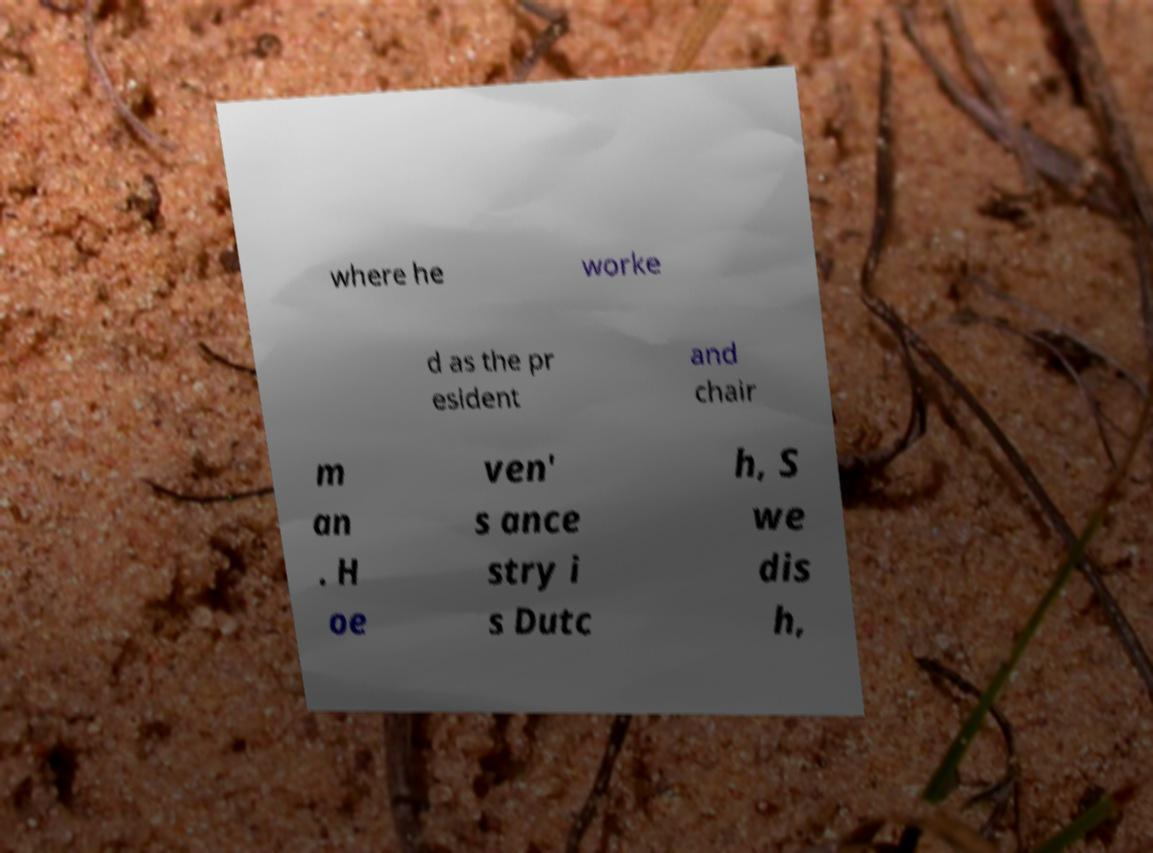What messages or text are displayed in this image? I need them in a readable, typed format. where he worke d as the pr esident and chair m an . H oe ven' s ance stry i s Dutc h, S we dis h, 